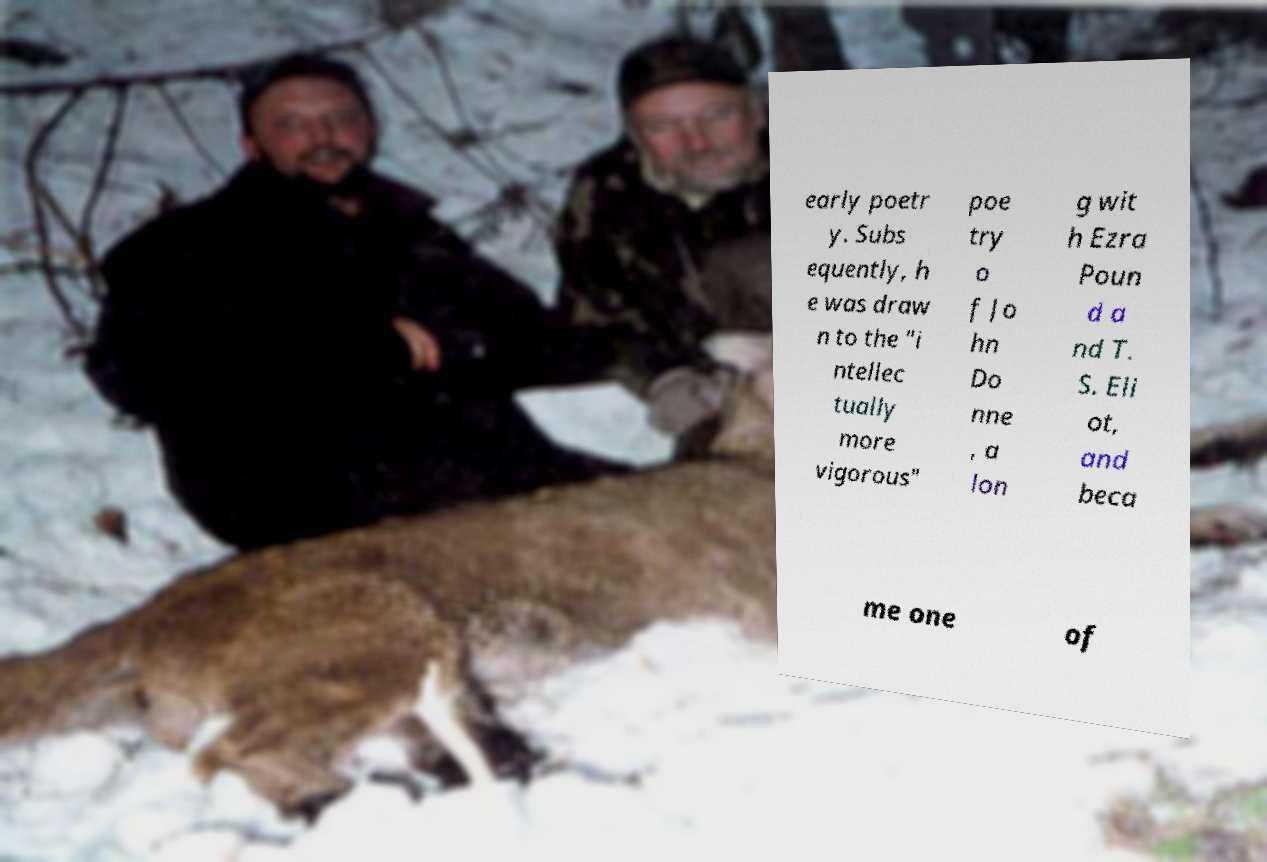There's text embedded in this image that I need extracted. Can you transcribe it verbatim? early poetr y. Subs equently, h e was draw n to the "i ntellec tually more vigorous" poe try o f Jo hn Do nne , a lon g wit h Ezra Poun d a nd T. S. Eli ot, and beca me one of 